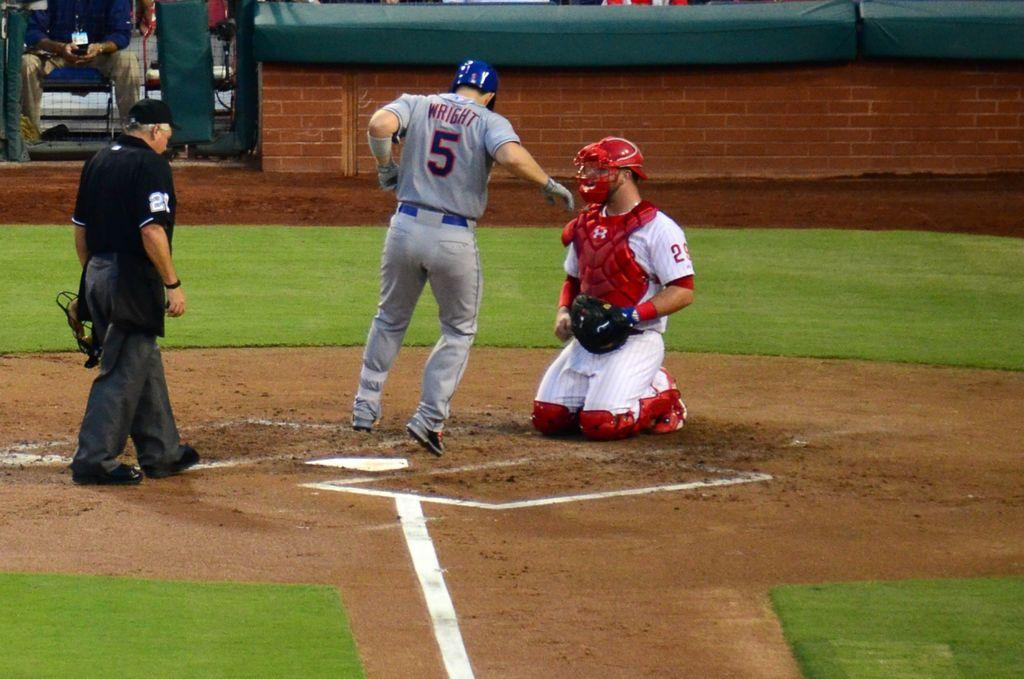<image>
Relay a brief, clear account of the picture shown. Wright wears player number 5 on his baseball team. 